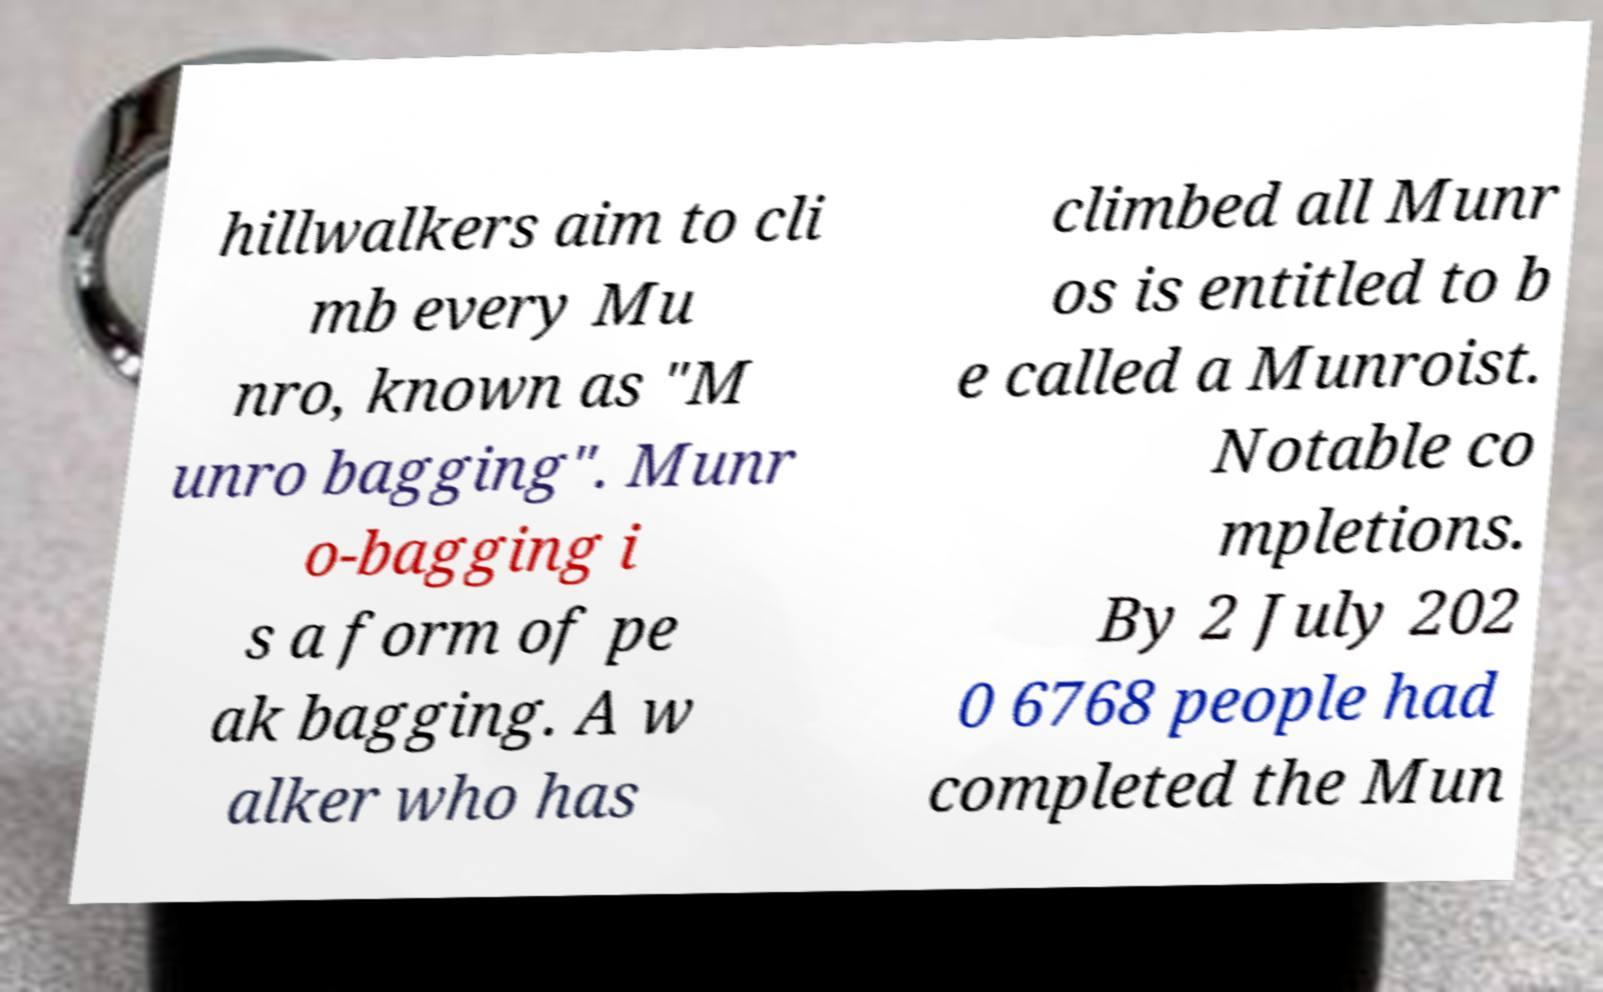Could you assist in decoding the text presented in this image and type it out clearly? hillwalkers aim to cli mb every Mu nro, known as "M unro bagging". Munr o-bagging i s a form of pe ak bagging. A w alker who has climbed all Munr os is entitled to b e called a Munroist. Notable co mpletions. By 2 July 202 0 6768 people had completed the Mun 